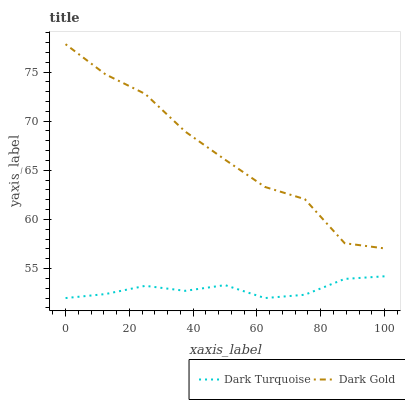Does Dark Turquoise have the minimum area under the curve?
Answer yes or no. Yes. Does Dark Gold have the maximum area under the curve?
Answer yes or no. Yes. Does Dark Gold have the minimum area under the curve?
Answer yes or no. No. Is Dark Turquoise the smoothest?
Answer yes or no. Yes. Is Dark Gold the roughest?
Answer yes or no. Yes. Is Dark Gold the smoothest?
Answer yes or no. No. Does Dark Turquoise have the lowest value?
Answer yes or no. Yes. Does Dark Gold have the lowest value?
Answer yes or no. No. Does Dark Gold have the highest value?
Answer yes or no. Yes. Is Dark Turquoise less than Dark Gold?
Answer yes or no. Yes. Is Dark Gold greater than Dark Turquoise?
Answer yes or no. Yes. Does Dark Turquoise intersect Dark Gold?
Answer yes or no. No. 